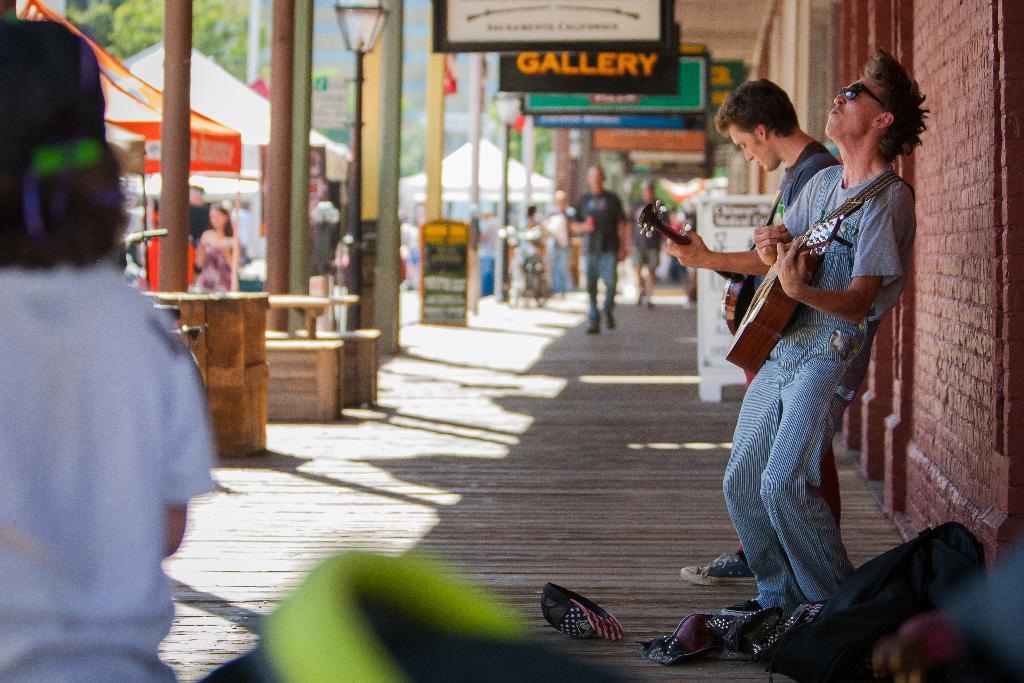Could you give a brief overview of what you see in this image? On the right two persons are standing and playing with guitar and also its brick wall in the left there are tents ,boards. 